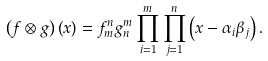Convert formula to latex. <formula><loc_0><loc_0><loc_500><loc_500>\left ( f \otimes g \right ) \left ( x \right ) = f _ { m } ^ { n } g _ { n } ^ { m } \prod _ { i = 1 } ^ { m } \prod _ { j = 1 } ^ { n } \left ( x - \alpha _ { i } \beta _ { j } \right ) .</formula> 